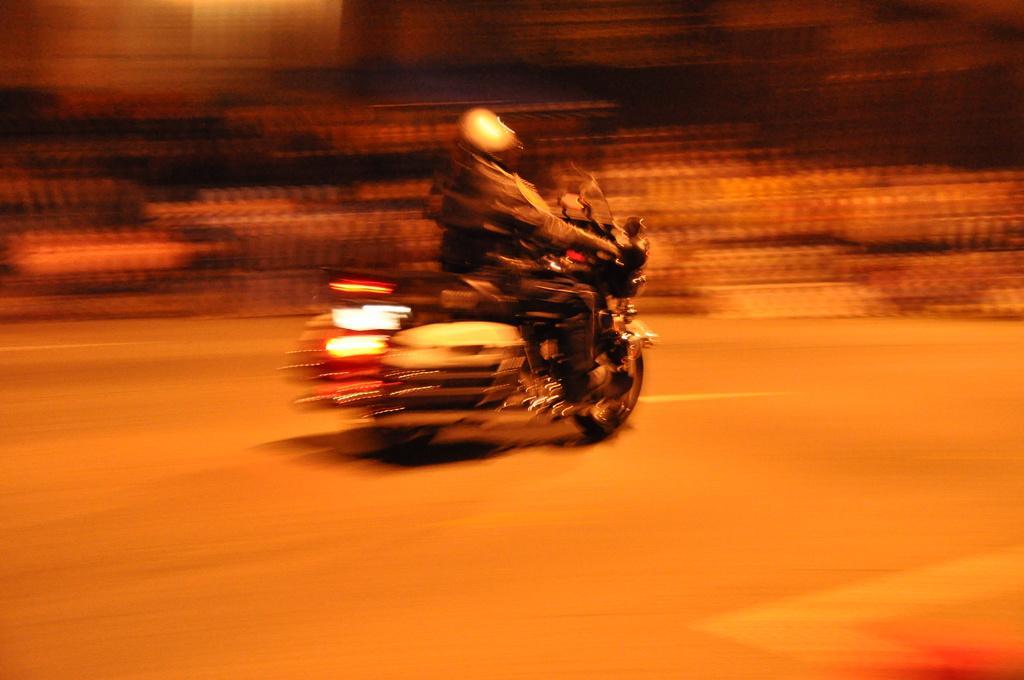Could you give a brief overview of what you see in this image? In the image we can see a person wearing clothes, helmet and the person is riding on the motorbike. The background is blurred. 